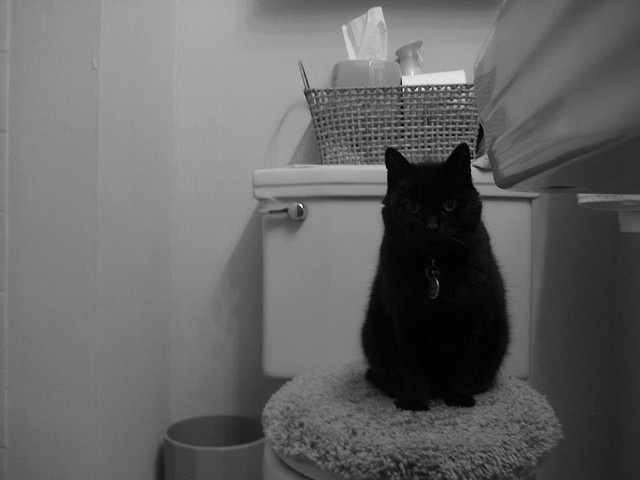Describe the objects in this image and their specific colors. I can see toilet in gray, black, and lightgray tones and cat in gray, black, and lightgray tones in this image. 